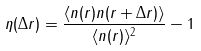<formula> <loc_0><loc_0><loc_500><loc_500>\eta ( \Delta r ) = \frac { \langle n ( r ) n ( r + \Delta r ) \rangle } { \langle n ( r ) \rangle ^ { 2 } } - 1</formula> 